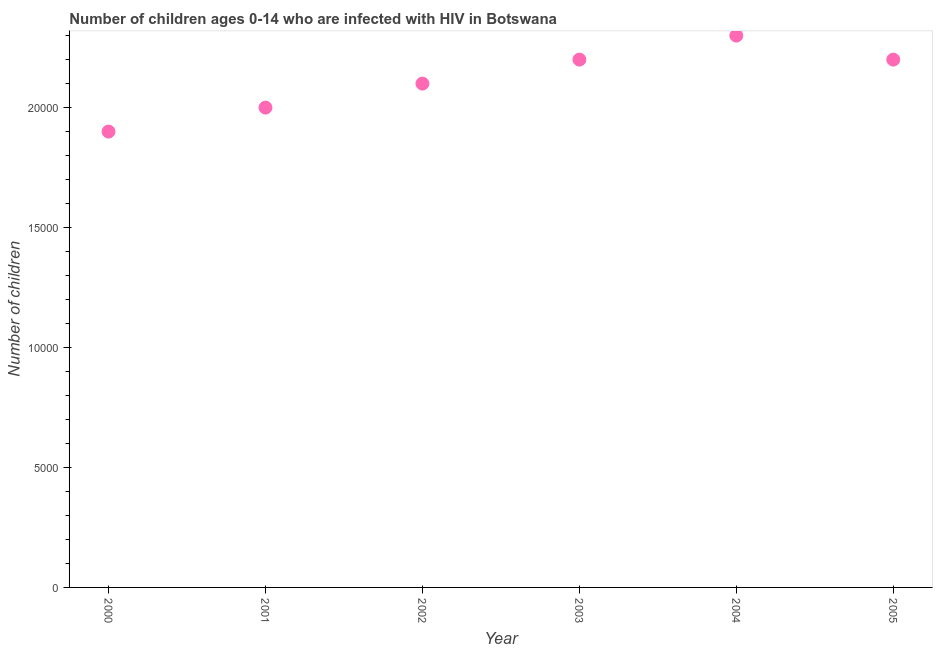What is the number of children living with hiv in 2004?
Offer a terse response. 2.30e+04. Across all years, what is the maximum number of children living with hiv?
Provide a succinct answer. 2.30e+04. Across all years, what is the minimum number of children living with hiv?
Your answer should be compact. 1.90e+04. In which year was the number of children living with hiv maximum?
Your response must be concise. 2004. In which year was the number of children living with hiv minimum?
Ensure brevity in your answer.  2000. What is the sum of the number of children living with hiv?
Your answer should be very brief. 1.27e+05. What is the difference between the number of children living with hiv in 2004 and 2005?
Make the answer very short. 1000. What is the average number of children living with hiv per year?
Provide a succinct answer. 2.12e+04. What is the median number of children living with hiv?
Give a very brief answer. 2.15e+04. In how many years, is the number of children living with hiv greater than 10000 ?
Your answer should be very brief. 6. What is the ratio of the number of children living with hiv in 2003 to that in 2004?
Offer a terse response. 0.96. Is the number of children living with hiv in 2003 less than that in 2004?
Make the answer very short. Yes. Is the difference between the number of children living with hiv in 2000 and 2002 greater than the difference between any two years?
Ensure brevity in your answer.  No. Is the sum of the number of children living with hiv in 2000 and 2001 greater than the maximum number of children living with hiv across all years?
Make the answer very short. Yes. What is the difference between the highest and the lowest number of children living with hiv?
Offer a very short reply. 4000. Does the number of children living with hiv monotonically increase over the years?
Keep it short and to the point. No. How many years are there in the graph?
Your answer should be compact. 6. Are the values on the major ticks of Y-axis written in scientific E-notation?
Make the answer very short. No. Does the graph contain grids?
Your response must be concise. No. What is the title of the graph?
Give a very brief answer. Number of children ages 0-14 who are infected with HIV in Botswana. What is the label or title of the Y-axis?
Make the answer very short. Number of children. What is the Number of children in 2000?
Provide a short and direct response. 1.90e+04. What is the Number of children in 2002?
Your response must be concise. 2.10e+04. What is the Number of children in 2003?
Provide a short and direct response. 2.20e+04. What is the Number of children in 2004?
Your response must be concise. 2.30e+04. What is the Number of children in 2005?
Make the answer very short. 2.20e+04. What is the difference between the Number of children in 2000 and 2001?
Provide a succinct answer. -1000. What is the difference between the Number of children in 2000 and 2002?
Your answer should be compact. -2000. What is the difference between the Number of children in 2000 and 2003?
Make the answer very short. -3000. What is the difference between the Number of children in 2000 and 2004?
Ensure brevity in your answer.  -4000. What is the difference between the Number of children in 2000 and 2005?
Offer a very short reply. -3000. What is the difference between the Number of children in 2001 and 2002?
Provide a short and direct response. -1000. What is the difference between the Number of children in 2001 and 2003?
Your answer should be compact. -2000. What is the difference between the Number of children in 2001 and 2004?
Provide a succinct answer. -3000. What is the difference between the Number of children in 2001 and 2005?
Provide a short and direct response. -2000. What is the difference between the Number of children in 2002 and 2003?
Offer a terse response. -1000. What is the difference between the Number of children in 2002 and 2004?
Give a very brief answer. -2000. What is the difference between the Number of children in 2002 and 2005?
Offer a terse response. -1000. What is the difference between the Number of children in 2003 and 2004?
Make the answer very short. -1000. What is the difference between the Number of children in 2003 and 2005?
Keep it short and to the point. 0. What is the difference between the Number of children in 2004 and 2005?
Provide a short and direct response. 1000. What is the ratio of the Number of children in 2000 to that in 2001?
Keep it short and to the point. 0.95. What is the ratio of the Number of children in 2000 to that in 2002?
Offer a very short reply. 0.91. What is the ratio of the Number of children in 2000 to that in 2003?
Make the answer very short. 0.86. What is the ratio of the Number of children in 2000 to that in 2004?
Ensure brevity in your answer.  0.83. What is the ratio of the Number of children in 2000 to that in 2005?
Offer a terse response. 0.86. What is the ratio of the Number of children in 2001 to that in 2003?
Ensure brevity in your answer.  0.91. What is the ratio of the Number of children in 2001 to that in 2004?
Give a very brief answer. 0.87. What is the ratio of the Number of children in 2001 to that in 2005?
Offer a terse response. 0.91. What is the ratio of the Number of children in 2002 to that in 2003?
Ensure brevity in your answer.  0.95. What is the ratio of the Number of children in 2002 to that in 2004?
Provide a short and direct response. 0.91. What is the ratio of the Number of children in 2002 to that in 2005?
Give a very brief answer. 0.95. What is the ratio of the Number of children in 2003 to that in 2004?
Your response must be concise. 0.96. What is the ratio of the Number of children in 2004 to that in 2005?
Your response must be concise. 1.04. 